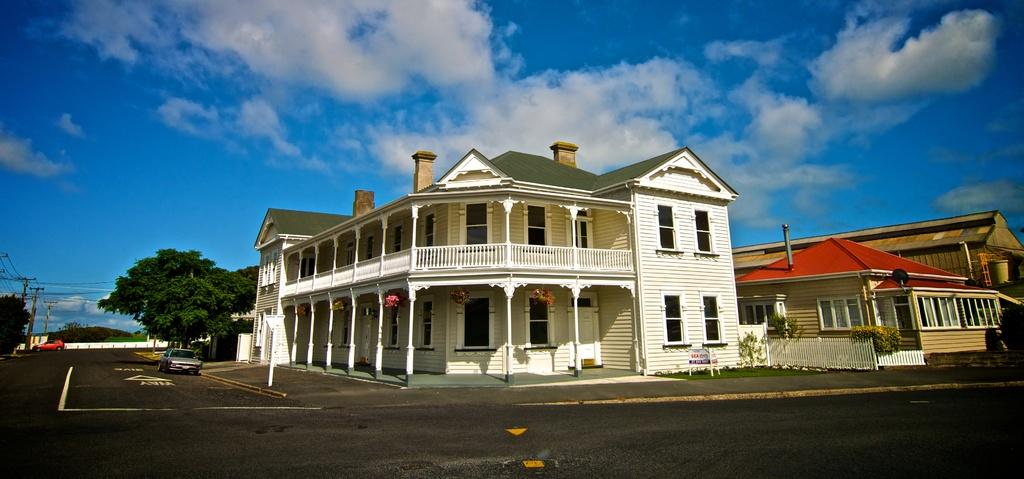What type of structures can be seen in the image? There are buildings in the image. What feature do the buildings have? The buildings have glass windows. What else can be seen in the image besides the buildings? Plants, vehicles, current poles, wires, a door, and trees are present in the image. What is the color of the sky in the image? The sky is blue and white in color. What type of lunch is being served in the image? There is no lunch present in the image; it features buildings, plants, vehicles, current poles, wires, a door, trees, and a blue and white sky. 